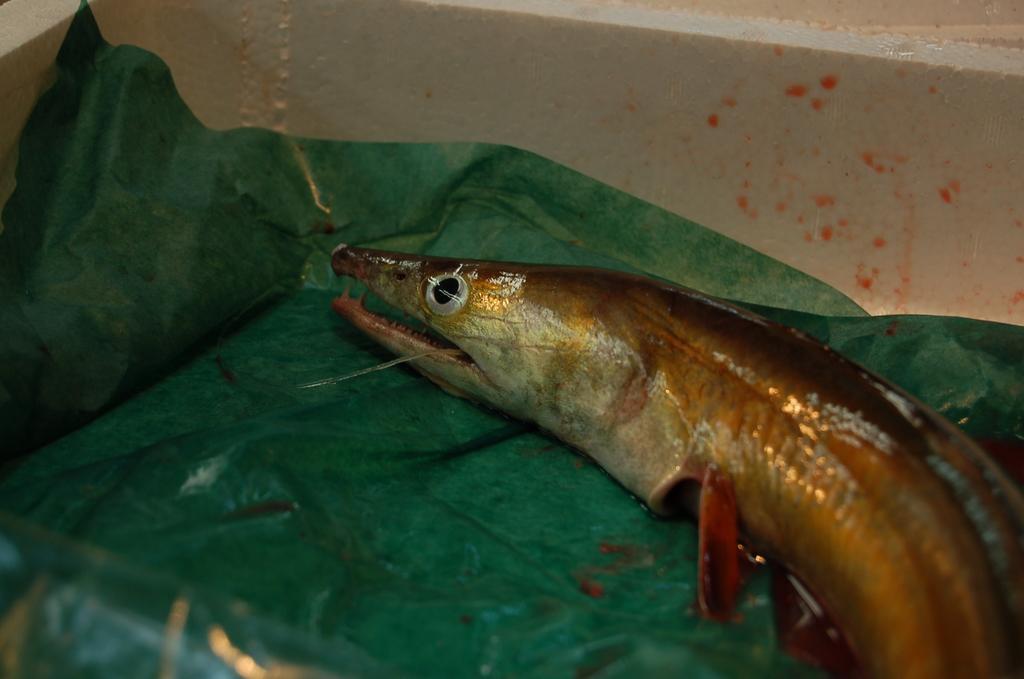Describe this image in one or two sentences. On this green surface we can see a fish. 